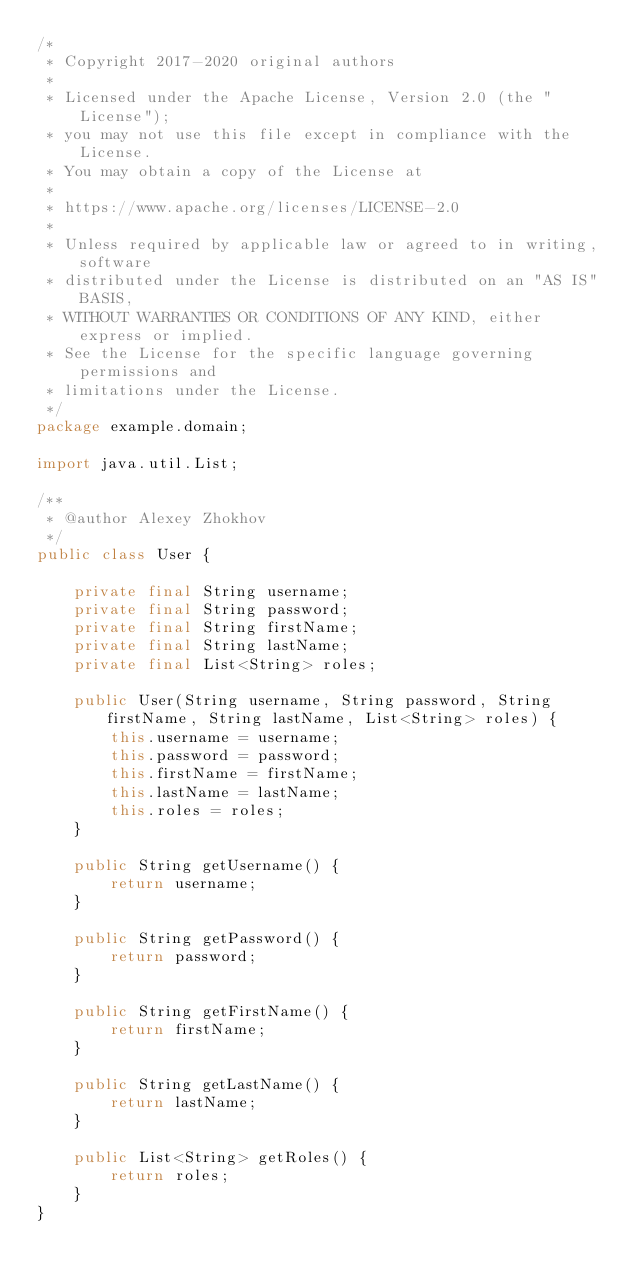<code> <loc_0><loc_0><loc_500><loc_500><_Java_>/*
 * Copyright 2017-2020 original authors
 *
 * Licensed under the Apache License, Version 2.0 (the "License");
 * you may not use this file except in compliance with the License.
 * You may obtain a copy of the License at
 *
 * https://www.apache.org/licenses/LICENSE-2.0
 *
 * Unless required by applicable law or agreed to in writing, software
 * distributed under the License is distributed on an "AS IS" BASIS,
 * WITHOUT WARRANTIES OR CONDITIONS OF ANY KIND, either express or implied.
 * See the License for the specific language governing permissions and
 * limitations under the License.
 */
package example.domain;

import java.util.List;

/**
 * @author Alexey Zhokhov
 */
public class User {

    private final String username;
    private final String password;
    private final String firstName;
    private final String lastName;
    private final List<String> roles;

    public User(String username, String password, String firstName, String lastName, List<String> roles) {
        this.username = username;
        this.password = password;
        this.firstName = firstName;
        this.lastName = lastName;
        this.roles = roles;
    }

    public String getUsername() {
        return username;
    }

    public String getPassword() {
        return password;
    }

    public String getFirstName() {
        return firstName;
    }

    public String getLastName() {
        return lastName;
    }

    public List<String> getRoles() {
        return roles;
    }
}
</code> 